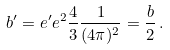<formula> <loc_0><loc_0><loc_500><loc_500>b ^ { \prime } = e ^ { \prime } e ^ { 2 } \frac { 4 } { 3 } \frac { 1 } { ( 4 \pi ) ^ { 2 } } = \frac { b } { 2 } \, .</formula> 